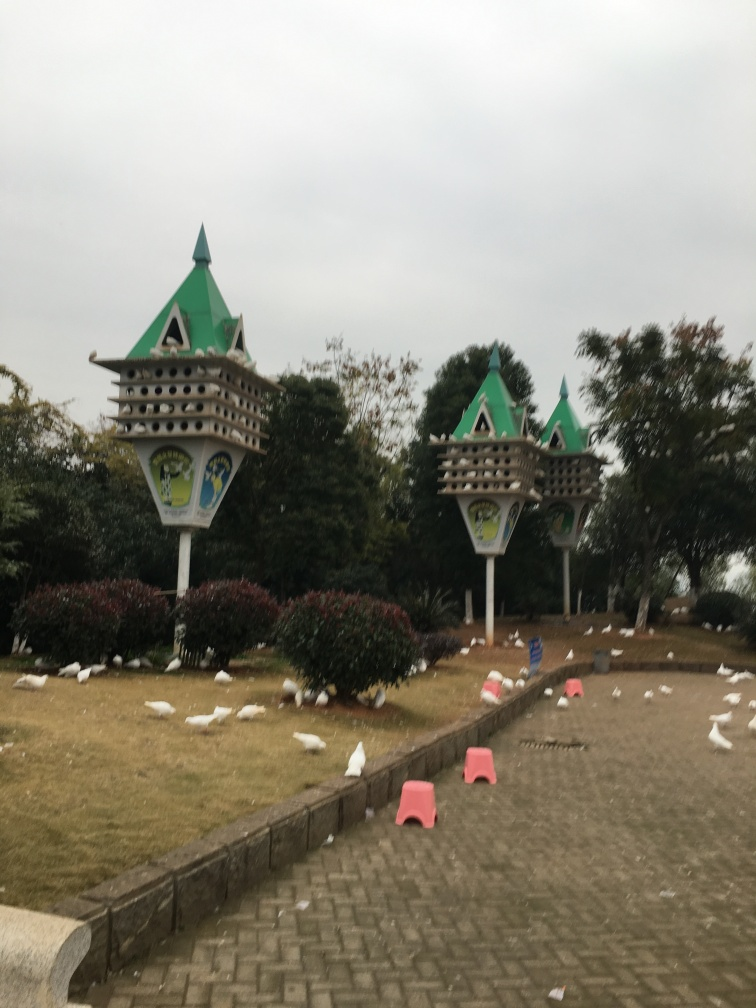Can you tell me what those structures in the image are used for? The structures resemble decorative birdhouses and may be intended as ornamental features in a park or garden, potentially offering shelter for birds. 